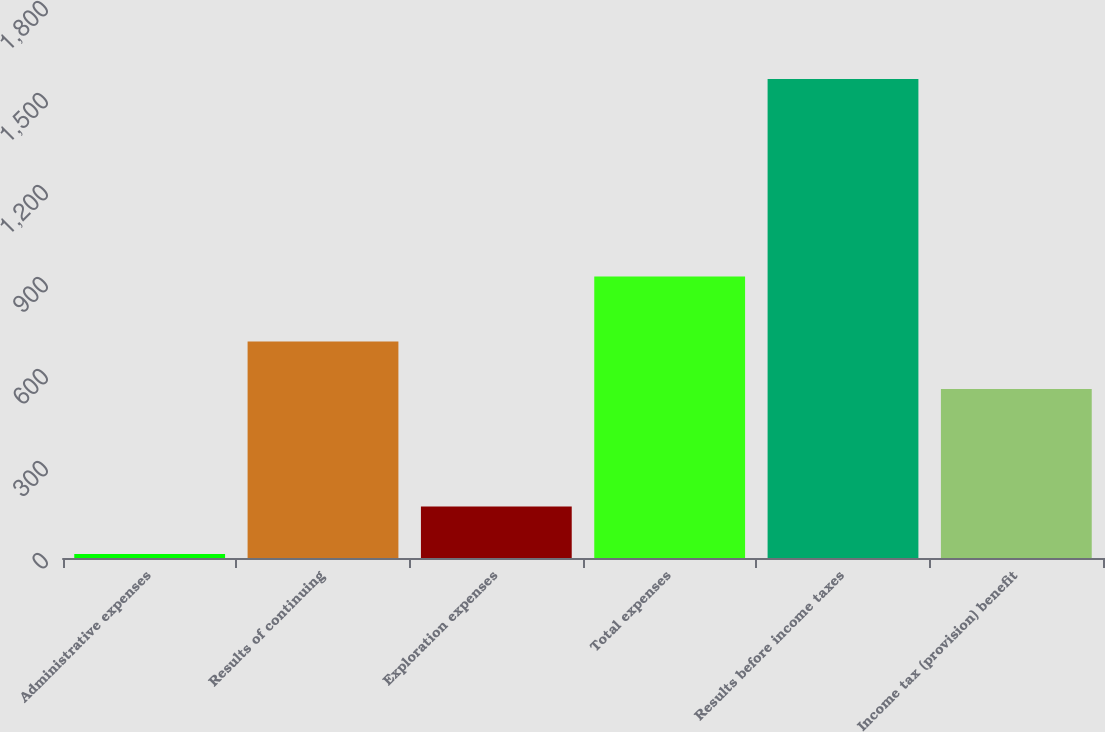<chart> <loc_0><loc_0><loc_500><loc_500><bar_chart><fcel>Administrative expenses<fcel>Results of continuing<fcel>Exploration expenses<fcel>Total expenses<fcel>Results before income taxes<fcel>Income tax (provision) benefit<nl><fcel>13<fcel>705.9<fcel>167.9<fcel>918<fcel>1562<fcel>551<nl></chart> 